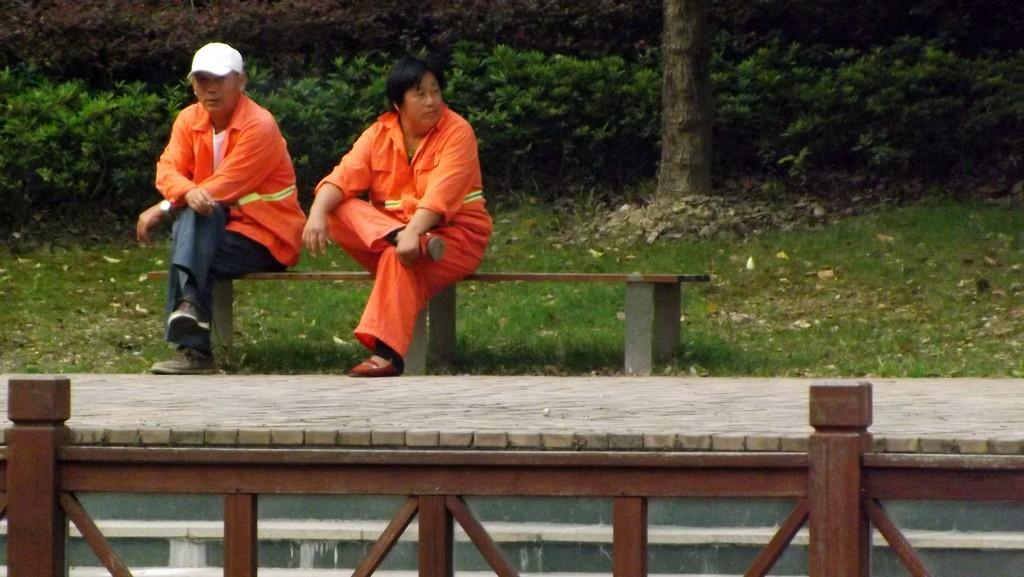How many people are sitting on the bench in the image? There are two people sitting on a bench in the image. What type of vegetation can be seen in the image? There are trees and plants in the image. What is at the bottom of the picture? There is a fencing at the bottom of the picture. What type of trouble are the pigs causing in the image? There are no pigs present in the image, so it is not possible to determine if they are causing any trouble. 